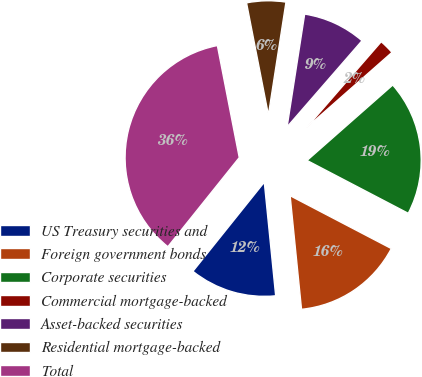Convert chart to OTSL. <chart><loc_0><loc_0><loc_500><loc_500><pie_chart><fcel>US Treasury securities and<fcel>Foreign government bonds<fcel>Corporate securities<fcel>Commercial mortgage-backed<fcel>Asset-backed securities<fcel>Residential mortgage-backed<fcel>Total<nl><fcel>12.34%<fcel>15.75%<fcel>19.15%<fcel>2.12%<fcel>8.93%<fcel>5.53%<fcel>36.18%<nl></chart> 